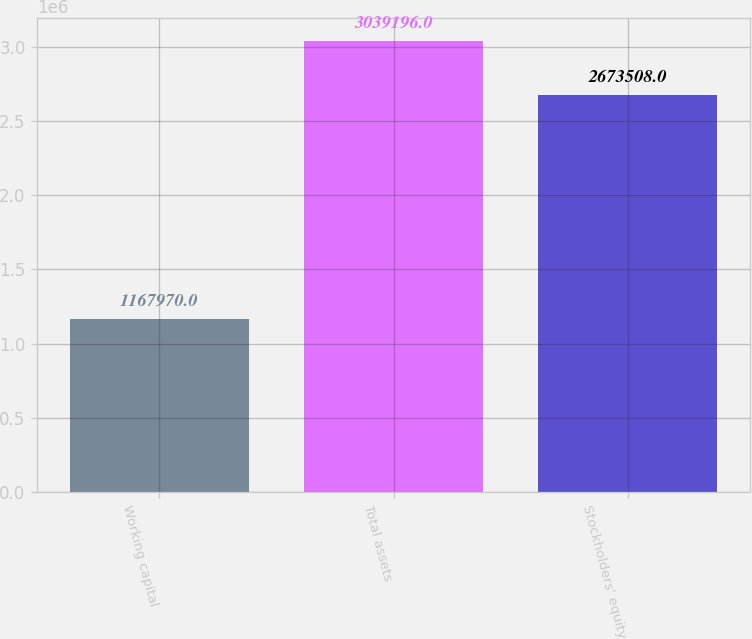Convert chart. <chart><loc_0><loc_0><loc_500><loc_500><bar_chart><fcel>Working capital<fcel>Total assets<fcel>Stockholders' equity<nl><fcel>1.16797e+06<fcel>3.0392e+06<fcel>2.67351e+06<nl></chart> 